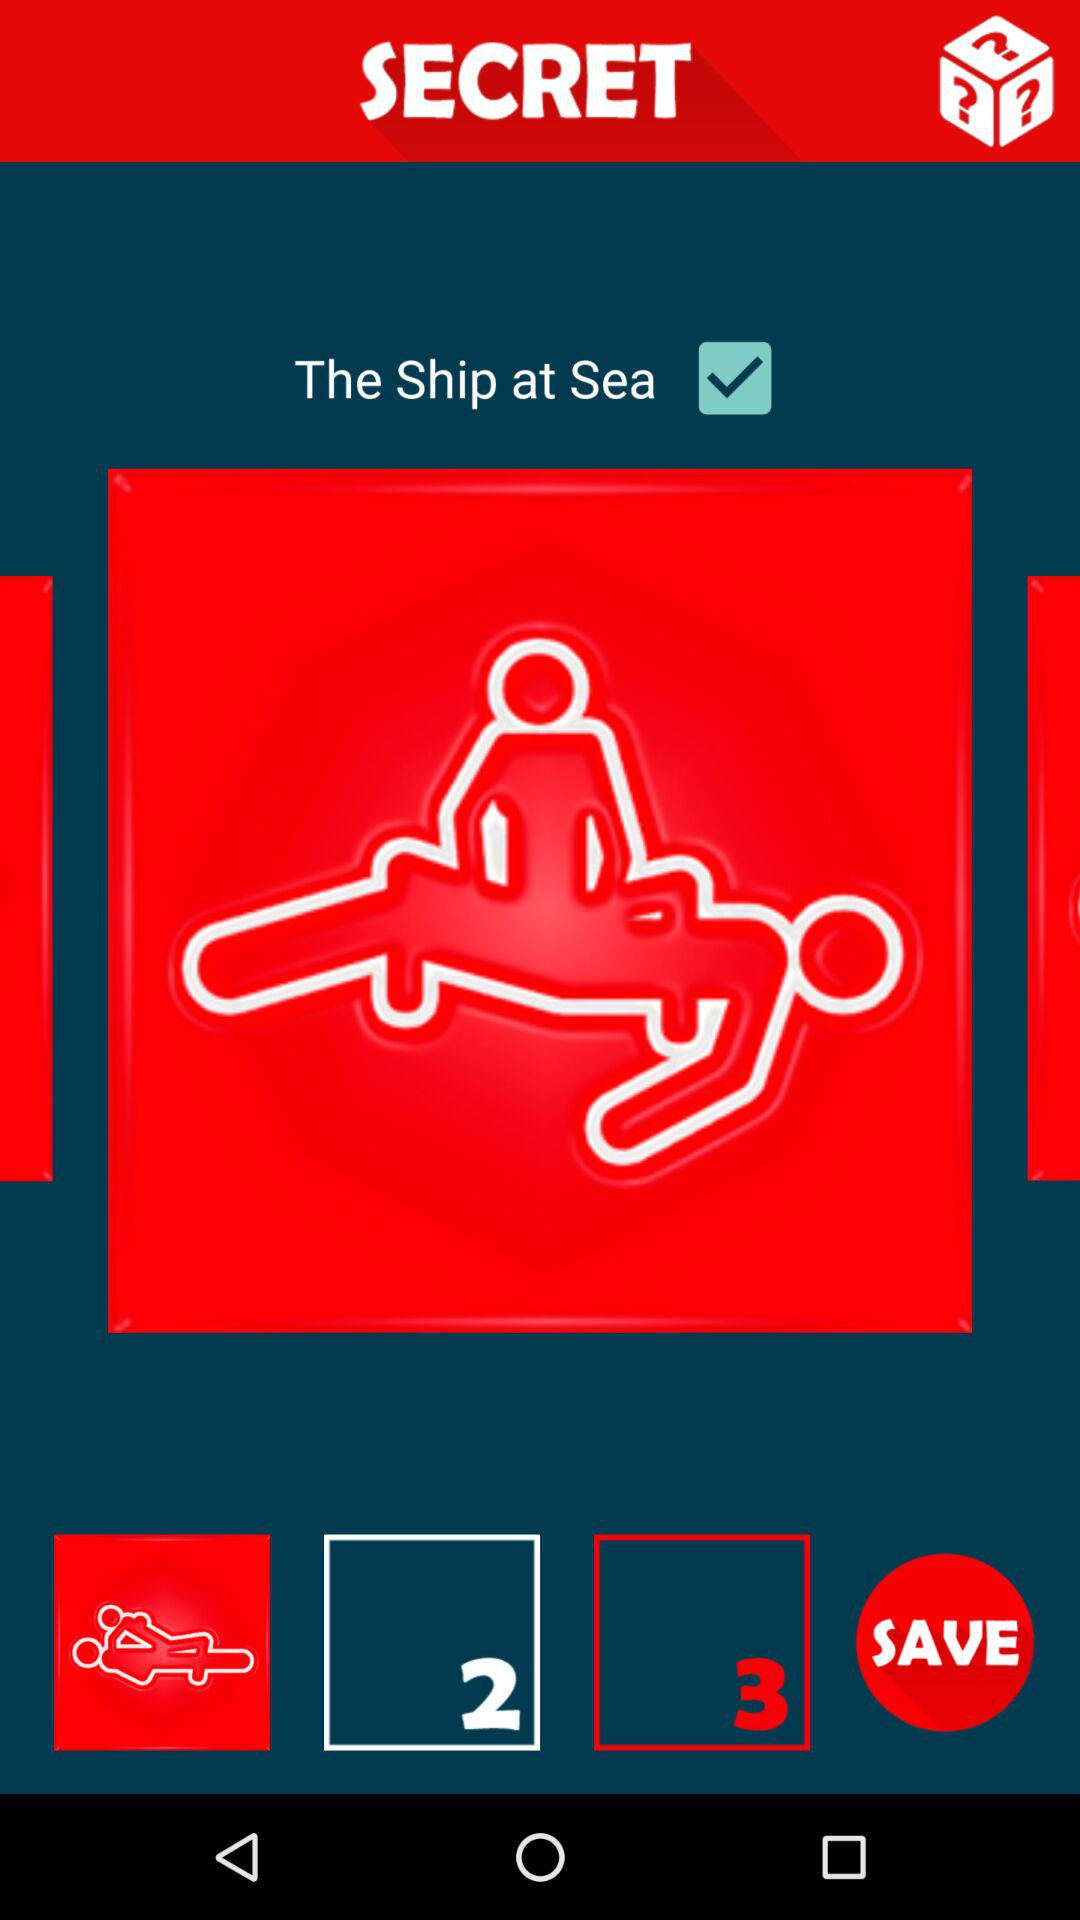What is the status of "The Ship at Sea"? The status is "on". 